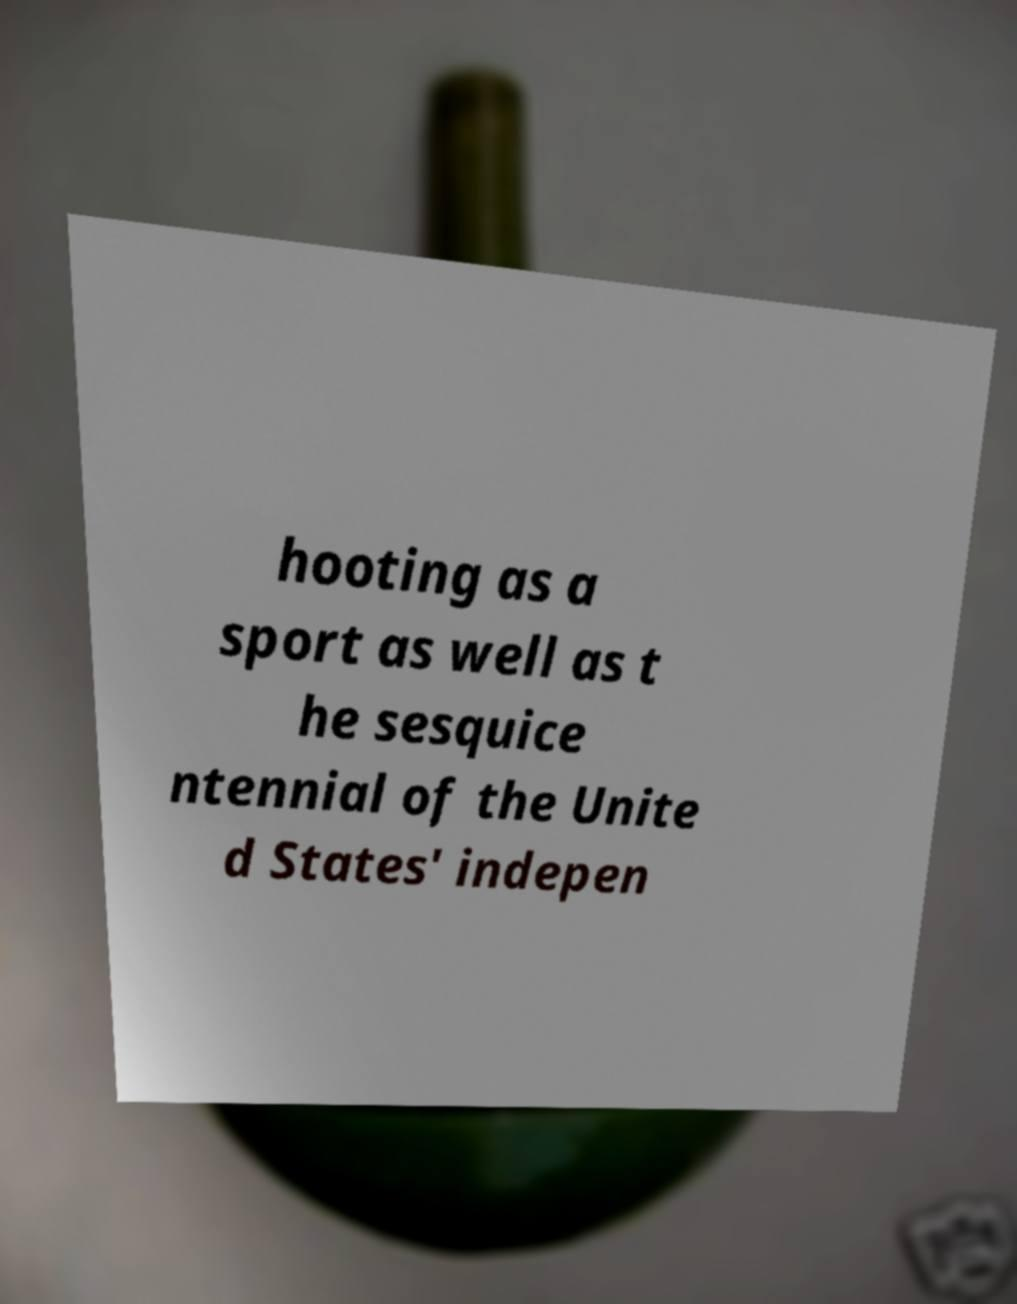Could you extract and type out the text from this image? hooting as a sport as well as t he sesquice ntennial of the Unite d States' indepen 